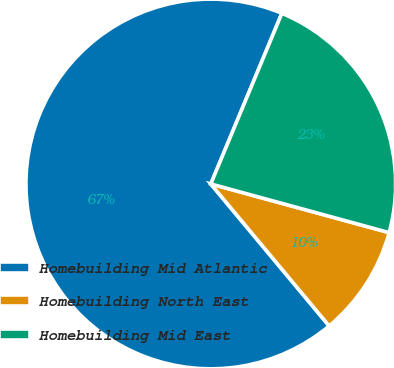Convert chart. <chart><loc_0><loc_0><loc_500><loc_500><pie_chart><fcel>Homebuilding Mid Atlantic<fcel>Homebuilding North East<fcel>Homebuilding Mid East<nl><fcel>67.34%<fcel>9.7%<fcel>22.96%<nl></chart> 